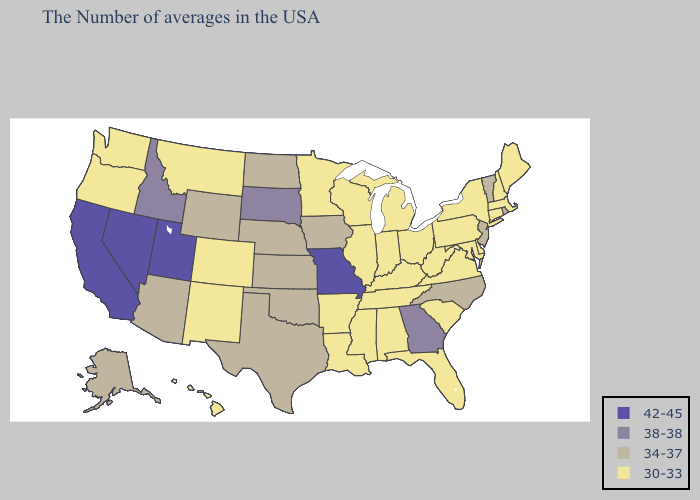Name the states that have a value in the range 42-45?
Short answer required. Missouri, Utah, Nevada, California. Among the states that border New Mexico , does Oklahoma have the highest value?
Write a very short answer. No. Name the states that have a value in the range 38-38?
Give a very brief answer. Georgia, South Dakota, Idaho. What is the value of Arizona?
Concise answer only. 34-37. Does Alabama have the same value as Ohio?
Short answer required. Yes. What is the value of Wyoming?
Quick response, please. 34-37. What is the value of Massachusetts?
Short answer required. 30-33. What is the value of Montana?
Concise answer only. 30-33. What is the lowest value in the West?
Give a very brief answer. 30-33. Does South Dakota have the lowest value in the MidWest?
Short answer required. No. Name the states that have a value in the range 38-38?
Short answer required. Georgia, South Dakota, Idaho. Name the states that have a value in the range 34-37?
Give a very brief answer. Rhode Island, Vermont, New Jersey, North Carolina, Iowa, Kansas, Nebraska, Oklahoma, Texas, North Dakota, Wyoming, Arizona, Alaska. What is the value of Minnesota?
Give a very brief answer. 30-33. Does the map have missing data?
Short answer required. No. Does Arizona have a higher value than Utah?
Be succinct. No. 